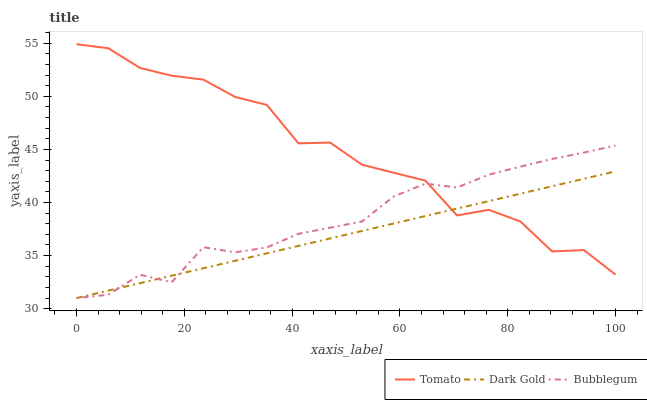Does Dark Gold have the minimum area under the curve?
Answer yes or no. Yes. Does Tomato have the maximum area under the curve?
Answer yes or no. Yes. Does Bubblegum have the minimum area under the curve?
Answer yes or no. No. Does Bubblegum have the maximum area under the curve?
Answer yes or no. No. Is Dark Gold the smoothest?
Answer yes or no. Yes. Is Tomato the roughest?
Answer yes or no. Yes. Is Bubblegum the smoothest?
Answer yes or no. No. Is Bubblegum the roughest?
Answer yes or no. No. Does Bubblegum have the lowest value?
Answer yes or no. Yes. Does Tomato have the highest value?
Answer yes or no. Yes. Does Bubblegum have the highest value?
Answer yes or no. No. Does Bubblegum intersect Dark Gold?
Answer yes or no. Yes. Is Bubblegum less than Dark Gold?
Answer yes or no. No. Is Bubblegum greater than Dark Gold?
Answer yes or no. No. 